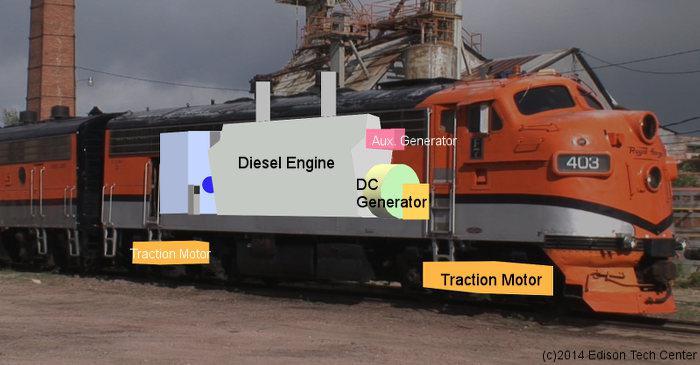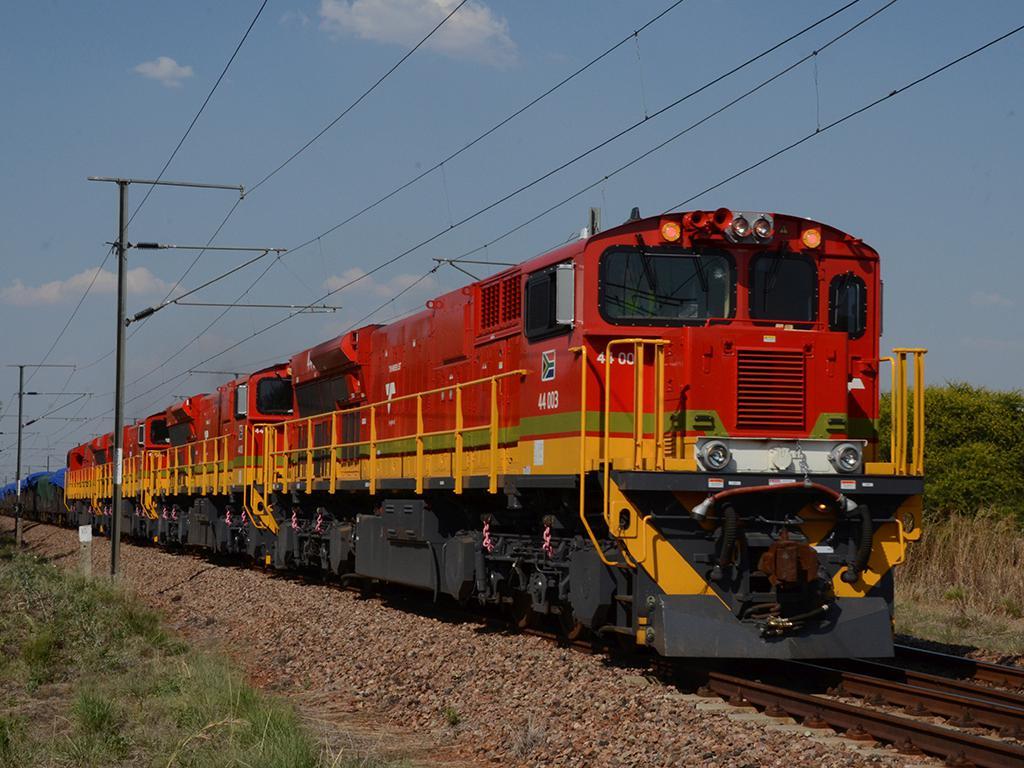The first image is the image on the left, the second image is the image on the right. Given the left and right images, does the statement "Thers is at least one ornage train." hold true? Answer yes or no. Yes. 